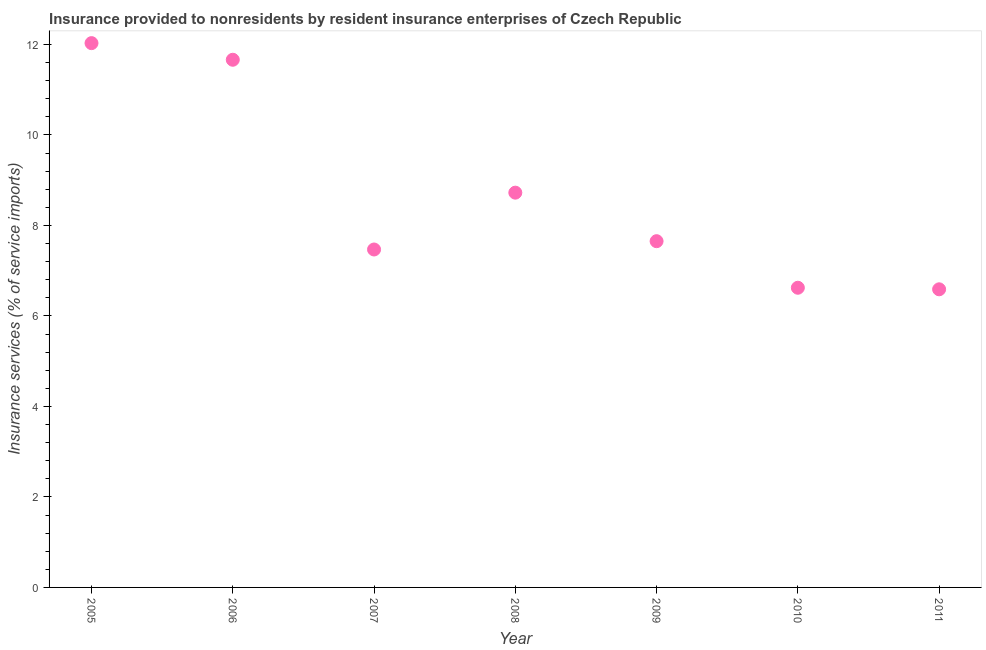What is the insurance and financial services in 2006?
Your response must be concise. 11.66. Across all years, what is the maximum insurance and financial services?
Keep it short and to the point. 12.03. Across all years, what is the minimum insurance and financial services?
Keep it short and to the point. 6.59. In which year was the insurance and financial services maximum?
Ensure brevity in your answer.  2005. In which year was the insurance and financial services minimum?
Offer a very short reply. 2011. What is the sum of the insurance and financial services?
Provide a succinct answer. 60.75. What is the difference between the insurance and financial services in 2005 and 2006?
Your answer should be compact. 0.37. What is the average insurance and financial services per year?
Offer a very short reply. 8.68. What is the median insurance and financial services?
Keep it short and to the point. 7.65. Do a majority of the years between 2006 and 2011 (inclusive) have insurance and financial services greater than 4 %?
Provide a short and direct response. Yes. What is the ratio of the insurance and financial services in 2006 to that in 2008?
Keep it short and to the point. 1.34. What is the difference between the highest and the second highest insurance and financial services?
Your answer should be compact. 0.37. Is the sum of the insurance and financial services in 2005 and 2007 greater than the maximum insurance and financial services across all years?
Give a very brief answer. Yes. What is the difference between the highest and the lowest insurance and financial services?
Make the answer very short. 5.44. In how many years, is the insurance and financial services greater than the average insurance and financial services taken over all years?
Your answer should be compact. 3. How many years are there in the graph?
Your answer should be very brief. 7. Does the graph contain any zero values?
Offer a very short reply. No. Does the graph contain grids?
Ensure brevity in your answer.  No. What is the title of the graph?
Your answer should be very brief. Insurance provided to nonresidents by resident insurance enterprises of Czech Republic. What is the label or title of the Y-axis?
Your response must be concise. Insurance services (% of service imports). What is the Insurance services (% of service imports) in 2005?
Your answer should be very brief. 12.03. What is the Insurance services (% of service imports) in 2006?
Make the answer very short. 11.66. What is the Insurance services (% of service imports) in 2007?
Your answer should be very brief. 7.47. What is the Insurance services (% of service imports) in 2008?
Offer a very short reply. 8.72. What is the Insurance services (% of service imports) in 2009?
Make the answer very short. 7.65. What is the Insurance services (% of service imports) in 2010?
Your answer should be very brief. 6.62. What is the Insurance services (% of service imports) in 2011?
Offer a very short reply. 6.59. What is the difference between the Insurance services (% of service imports) in 2005 and 2006?
Offer a terse response. 0.37. What is the difference between the Insurance services (% of service imports) in 2005 and 2007?
Your answer should be very brief. 4.56. What is the difference between the Insurance services (% of service imports) in 2005 and 2008?
Your answer should be very brief. 3.3. What is the difference between the Insurance services (% of service imports) in 2005 and 2009?
Provide a short and direct response. 4.38. What is the difference between the Insurance services (% of service imports) in 2005 and 2010?
Offer a terse response. 5.41. What is the difference between the Insurance services (% of service imports) in 2005 and 2011?
Keep it short and to the point. 5.44. What is the difference between the Insurance services (% of service imports) in 2006 and 2007?
Your response must be concise. 4.19. What is the difference between the Insurance services (% of service imports) in 2006 and 2008?
Offer a terse response. 2.94. What is the difference between the Insurance services (% of service imports) in 2006 and 2009?
Ensure brevity in your answer.  4.01. What is the difference between the Insurance services (% of service imports) in 2006 and 2010?
Provide a succinct answer. 5.04. What is the difference between the Insurance services (% of service imports) in 2006 and 2011?
Your answer should be very brief. 5.07. What is the difference between the Insurance services (% of service imports) in 2007 and 2008?
Keep it short and to the point. -1.26. What is the difference between the Insurance services (% of service imports) in 2007 and 2009?
Your answer should be very brief. -0.18. What is the difference between the Insurance services (% of service imports) in 2007 and 2010?
Your answer should be very brief. 0.85. What is the difference between the Insurance services (% of service imports) in 2007 and 2011?
Your answer should be compact. 0.88. What is the difference between the Insurance services (% of service imports) in 2008 and 2009?
Ensure brevity in your answer.  1.07. What is the difference between the Insurance services (% of service imports) in 2008 and 2010?
Give a very brief answer. 2.1. What is the difference between the Insurance services (% of service imports) in 2008 and 2011?
Your response must be concise. 2.14. What is the difference between the Insurance services (% of service imports) in 2009 and 2010?
Provide a succinct answer. 1.03. What is the difference between the Insurance services (% of service imports) in 2009 and 2011?
Your response must be concise. 1.06. What is the difference between the Insurance services (% of service imports) in 2010 and 2011?
Your response must be concise. 0.03. What is the ratio of the Insurance services (% of service imports) in 2005 to that in 2006?
Give a very brief answer. 1.03. What is the ratio of the Insurance services (% of service imports) in 2005 to that in 2007?
Make the answer very short. 1.61. What is the ratio of the Insurance services (% of service imports) in 2005 to that in 2008?
Provide a short and direct response. 1.38. What is the ratio of the Insurance services (% of service imports) in 2005 to that in 2009?
Your answer should be very brief. 1.57. What is the ratio of the Insurance services (% of service imports) in 2005 to that in 2010?
Offer a very short reply. 1.82. What is the ratio of the Insurance services (% of service imports) in 2005 to that in 2011?
Give a very brief answer. 1.83. What is the ratio of the Insurance services (% of service imports) in 2006 to that in 2007?
Make the answer very short. 1.56. What is the ratio of the Insurance services (% of service imports) in 2006 to that in 2008?
Make the answer very short. 1.34. What is the ratio of the Insurance services (% of service imports) in 2006 to that in 2009?
Provide a succinct answer. 1.52. What is the ratio of the Insurance services (% of service imports) in 2006 to that in 2010?
Ensure brevity in your answer.  1.76. What is the ratio of the Insurance services (% of service imports) in 2006 to that in 2011?
Your answer should be compact. 1.77. What is the ratio of the Insurance services (% of service imports) in 2007 to that in 2008?
Give a very brief answer. 0.86. What is the ratio of the Insurance services (% of service imports) in 2007 to that in 2010?
Provide a short and direct response. 1.13. What is the ratio of the Insurance services (% of service imports) in 2007 to that in 2011?
Provide a succinct answer. 1.13. What is the ratio of the Insurance services (% of service imports) in 2008 to that in 2009?
Offer a terse response. 1.14. What is the ratio of the Insurance services (% of service imports) in 2008 to that in 2010?
Offer a very short reply. 1.32. What is the ratio of the Insurance services (% of service imports) in 2008 to that in 2011?
Your response must be concise. 1.32. What is the ratio of the Insurance services (% of service imports) in 2009 to that in 2010?
Keep it short and to the point. 1.16. What is the ratio of the Insurance services (% of service imports) in 2009 to that in 2011?
Your answer should be very brief. 1.16. What is the ratio of the Insurance services (% of service imports) in 2010 to that in 2011?
Offer a very short reply. 1. 